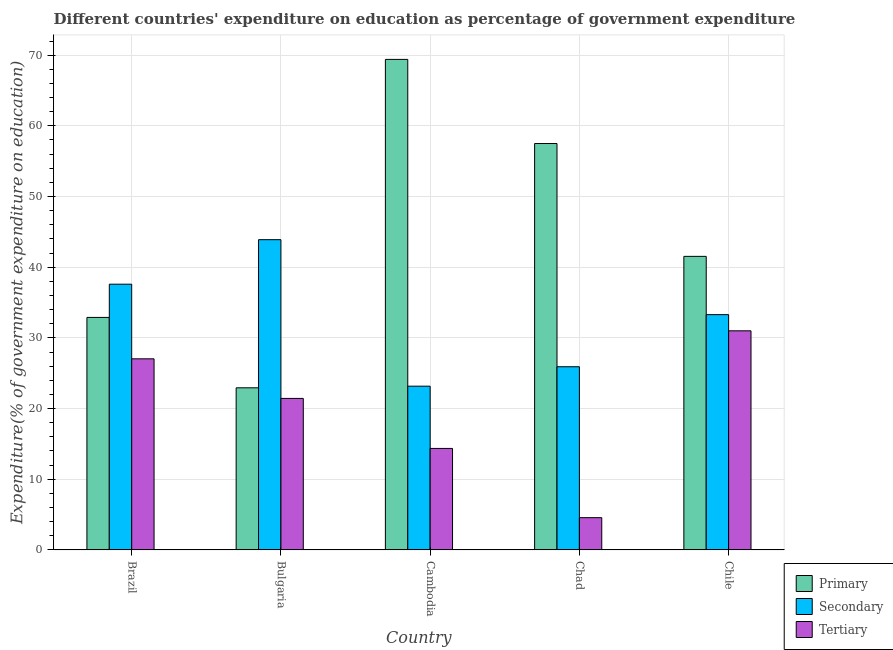How many different coloured bars are there?
Provide a succinct answer. 3. How many groups of bars are there?
Provide a short and direct response. 5. How many bars are there on the 5th tick from the right?
Make the answer very short. 3. What is the label of the 2nd group of bars from the left?
Provide a short and direct response. Bulgaria. What is the expenditure on primary education in Chile?
Your answer should be compact. 41.54. Across all countries, what is the maximum expenditure on secondary education?
Your answer should be compact. 43.9. Across all countries, what is the minimum expenditure on tertiary education?
Provide a short and direct response. 4.57. In which country was the expenditure on primary education maximum?
Your answer should be compact. Cambodia. In which country was the expenditure on secondary education minimum?
Offer a terse response. Cambodia. What is the total expenditure on secondary education in the graph?
Your answer should be very brief. 163.87. What is the difference between the expenditure on secondary education in Bulgaria and that in Cambodia?
Keep it short and to the point. 20.73. What is the difference between the expenditure on primary education in Bulgaria and the expenditure on tertiary education in Chile?
Offer a terse response. -8.06. What is the average expenditure on primary education per country?
Your answer should be compact. 44.85. What is the difference between the expenditure on secondary education and expenditure on tertiary education in Brazil?
Offer a terse response. 10.56. In how many countries, is the expenditure on tertiary education greater than 68 %?
Offer a very short reply. 0. What is the ratio of the expenditure on secondary education in Bulgaria to that in Chad?
Ensure brevity in your answer.  1.69. Is the expenditure on tertiary education in Brazil less than that in Chad?
Provide a short and direct response. No. Is the difference between the expenditure on secondary education in Bulgaria and Chile greater than the difference between the expenditure on tertiary education in Bulgaria and Chile?
Your response must be concise. Yes. What is the difference between the highest and the second highest expenditure on tertiary education?
Your answer should be compact. 3.96. What is the difference between the highest and the lowest expenditure on tertiary education?
Offer a very short reply. 26.43. What does the 2nd bar from the left in Bulgaria represents?
Offer a terse response. Secondary. What does the 2nd bar from the right in Brazil represents?
Ensure brevity in your answer.  Secondary. Is it the case that in every country, the sum of the expenditure on primary education and expenditure on secondary education is greater than the expenditure on tertiary education?
Your answer should be compact. Yes. How many bars are there?
Provide a short and direct response. 15. Are all the bars in the graph horizontal?
Provide a short and direct response. No. Are the values on the major ticks of Y-axis written in scientific E-notation?
Provide a short and direct response. No. How many legend labels are there?
Give a very brief answer. 3. How are the legend labels stacked?
Your response must be concise. Vertical. What is the title of the graph?
Make the answer very short. Different countries' expenditure on education as percentage of government expenditure. Does "Negligence towards kids" appear as one of the legend labels in the graph?
Offer a very short reply. No. What is the label or title of the X-axis?
Provide a succinct answer. Country. What is the label or title of the Y-axis?
Your answer should be very brief. Expenditure(% of government expenditure on education). What is the Expenditure(% of government expenditure on education) in Primary in Brazil?
Your answer should be compact. 32.9. What is the Expenditure(% of government expenditure on education) in Secondary in Brazil?
Provide a succinct answer. 37.6. What is the Expenditure(% of government expenditure on education) of Tertiary in Brazil?
Your answer should be very brief. 27.04. What is the Expenditure(% of government expenditure on education) in Primary in Bulgaria?
Provide a succinct answer. 22.94. What is the Expenditure(% of government expenditure on education) of Secondary in Bulgaria?
Your answer should be very brief. 43.9. What is the Expenditure(% of government expenditure on education) of Tertiary in Bulgaria?
Ensure brevity in your answer.  21.44. What is the Expenditure(% of government expenditure on education) of Primary in Cambodia?
Your answer should be compact. 69.4. What is the Expenditure(% of government expenditure on education) of Secondary in Cambodia?
Keep it short and to the point. 23.17. What is the Expenditure(% of government expenditure on education) in Tertiary in Cambodia?
Provide a succinct answer. 14.36. What is the Expenditure(% of government expenditure on education) in Primary in Chad?
Offer a very short reply. 57.5. What is the Expenditure(% of government expenditure on education) in Secondary in Chad?
Provide a succinct answer. 25.92. What is the Expenditure(% of government expenditure on education) of Tertiary in Chad?
Keep it short and to the point. 4.57. What is the Expenditure(% of government expenditure on education) in Primary in Chile?
Provide a short and direct response. 41.54. What is the Expenditure(% of government expenditure on education) in Secondary in Chile?
Provide a short and direct response. 33.29. What is the Expenditure(% of government expenditure on education) of Tertiary in Chile?
Provide a succinct answer. 31. Across all countries, what is the maximum Expenditure(% of government expenditure on education) of Primary?
Give a very brief answer. 69.4. Across all countries, what is the maximum Expenditure(% of government expenditure on education) of Secondary?
Provide a succinct answer. 43.9. Across all countries, what is the maximum Expenditure(% of government expenditure on education) in Tertiary?
Offer a terse response. 31. Across all countries, what is the minimum Expenditure(% of government expenditure on education) in Primary?
Keep it short and to the point. 22.94. Across all countries, what is the minimum Expenditure(% of government expenditure on education) in Secondary?
Offer a terse response. 23.17. Across all countries, what is the minimum Expenditure(% of government expenditure on education) of Tertiary?
Your answer should be compact. 4.57. What is the total Expenditure(% of government expenditure on education) in Primary in the graph?
Provide a succinct answer. 224.27. What is the total Expenditure(% of government expenditure on education) of Secondary in the graph?
Ensure brevity in your answer.  163.87. What is the total Expenditure(% of government expenditure on education) in Tertiary in the graph?
Make the answer very short. 98.4. What is the difference between the Expenditure(% of government expenditure on education) in Primary in Brazil and that in Bulgaria?
Ensure brevity in your answer.  9.96. What is the difference between the Expenditure(% of government expenditure on education) of Secondary in Brazil and that in Bulgaria?
Your response must be concise. -6.3. What is the difference between the Expenditure(% of government expenditure on education) in Tertiary in Brazil and that in Bulgaria?
Provide a short and direct response. 5.6. What is the difference between the Expenditure(% of government expenditure on education) of Primary in Brazil and that in Cambodia?
Your answer should be very brief. -36.5. What is the difference between the Expenditure(% of government expenditure on education) of Secondary in Brazil and that in Cambodia?
Offer a terse response. 14.43. What is the difference between the Expenditure(% of government expenditure on education) in Tertiary in Brazil and that in Cambodia?
Offer a very short reply. 12.68. What is the difference between the Expenditure(% of government expenditure on education) in Primary in Brazil and that in Chad?
Ensure brevity in your answer.  -24.6. What is the difference between the Expenditure(% of government expenditure on education) in Secondary in Brazil and that in Chad?
Your answer should be very brief. 11.68. What is the difference between the Expenditure(% of government expenditure on education) of Tertiary in Brazil and that in Chad?
Offer a terse response. 22.47. What is the difference between the Expenditure(% of government expenditure on education) in Primary in Brazil and that in Chile?
Your response must be concise. -8.64. What is the difference between the Expenditure(% of government expenditure on education) in Secondary in Brazil and that in Chile?
Provide a short and direct response. 4.31. What is the difference between the Expenditure(% of government expenditure on education) in Tertiary in Brazil and that in Chile?
Your answer should be compact. -3.96. What is the difference between the Expenditure(% of government expenditure on education) in Primary in Bulgaria and that in Cambodia?
Ensure brevity in your answer.  -46.46. What is the difference between the Expenditure(% of government expenditure on education) in Secondary in Bulgaria and that in Cambodia?
Keep it short and to the point. 20.73. What is the difference between the Expenditure(% of government expenditure on education) of Tertiary in Bulgaria and that in Cambodia?
Offer a terse response. 7.08. What is the difference between the Expenditure(% of government expenditure on education) of Primary in Bulgaria and that in Chad?
Provide a succinct answer. -34.56. What is the difference between the Expenditure(% of government expenditure on education) in Secondary in Bulgaria and that in Chad?
Make the answer very short. 17.98. What is the difference between the Expenditure(% of government expenditure on education) in Tertiary in Bulgaria and that in Chad?
Offer a very short reply. 16.87. What is the difference between the Expenditure(% of government expenditure on education) in Primary in Bulgaria and that in Chile?
Your response must be concise. -18.6. What is the difference between the Expenditure(% of government expenditure on education) of Secondary in Bulgaria and that in Chile?
Provide a succinct answer. 10.61. What is the difference between the Expenditure(% of government expenditure on education) in Tertiary in Bulgaria and that in Chile?
Ensure brevity in your answer.  -9.56. What is the difference between the Expenditure(% of government expenditure on education) in Primary in Cambodia and that in Chad?
Your answer should be compact. 11.9. What is the difference between the Expenditure(% of government expenditure on education) in Secondary in Cambodia and that in Chad?
Ensure brevity in your answer.  -2.75. What is the difference between the Expenditure(% of government expenditure on education) of Tertiary in Cambodia and that in Chad?
Your answer should be compact. 9.79. What is the difference between the Expenditure(% of government expenditure on education) of Primary in Cambodia and that in Chile?
Your response must be concise. 27.87. What is the difference between the Expenditure(% of government expenditure on education) of Secondary in Cambodia and that in Chile?
Your answer should be very brief. -10.12. What is the difference between the Expenditure(% of government expenditure on education) of Tertiary in Cambodia and that in Chile?
Provide a short and direct response. -16.64. What is the difference between the Expenditure(% of government expenditure on education) in Primary in Chad and that in Chile?
Your response must be concise. 15.96. What is the difference between the Expenditure(% of government expenditure on education) of Secondary in Chad and that in Chile?
Provide a succinct answer. -7.37. What is the difference between the Expenditure(% of government expenditure on education) in Tertiary in Chad and that in Chile?
Provide a succinct answer. -26.43. What is the difference between the Expenditure(% of government expenditure on education) in Primary in Brazil and the Expenditure(% of government expenditure on education) in Secondary in Bulgaria?
Offer a very short reply. -11. What is the difference between the Expenditure(% of government expenditure on education) of Primary in Brazil and the Expenditure(% of government expenditure on education) of Tertiary in Bulgaria?
Provide a succinct answer. 11.46. What is the difference between the Expenditure(% of government expenditure on education) of Secondary in Brazil and the Expenditure(% of government expenditure on education) of Tertiary in Bulgaria?
Provide a short and direct response. 16.16. What is the difference between the Expenditure(% of government expenditure on education) of Primary in Brazil and the Expenditure(% of government expenditure on education) of Secondary in Cambodia?
Your answer should be very brief. 9.73. What is the difference between the Expenditure(% of government expenditure on education) in Primary in Brazil and the Expenditure(% of government expenditure on education) in Tertiary in Cambodia?
Keep it short and to the point. 18.54. What is the difference between the Expenditure(% of government expenditure on education) of Secondary in Brazil and the Expenditure(% of government expenditure on education) of Tertiary in Cambodia?
Make the answer very short. 23.24. What is the difference between the Expenditure(% of government expenditure on education) in Primary in Brazil and the Expenditure(% of government expenditure on education) in Secondary in Chad?
Your response must be concise. 6.98. What is the difference between the Expenditure(% of government expenditure on education) of Primary in Brazil and the Expenditure(% of government expenditure on education) of Tertiary in Chad?
Offer a terse response. 28.33. What is the difference between the Expenditure(% of government expenditure on education) of Secondary in Brazil and the Expenditure(% of government expenditure on education) of Tertiary in Chad?
Provide a short and direct response. 33.03. What is the difference between the Expenditure(% of government expenditure on education) of Primary in Brazil and the Expenditure(% of government expenditure on education) of Secondary in Chile?
Your answer should be compact. -0.39. What is the difference between the Expenditure(% of government expenditure on education) in Primary in Brazil and the Expenditure(% of government expenditure on education) in Tertiary in Chile?
Your response must be concise. 1.9. What is the difference between the Expenditure(% of government expenditure on education) in Secondary in Brazil and the Expenditure(% of government expenditure on education) in Tertiary in Chile?
Give a very brief answer. 6.6. What is the difference between the Expenditure(% of government expenditure on education) in Primary in Bulgaria and the Expenditure(% of government expenditure on education) in Secondary in Cambodia?
Offer a terse response. -0.23. What is the difference between the Expenditure(% of government expenditure on education) of Primary in Bulgaria and the Expenditure(% of government expenditure on education) of Tertiary in Cambodia?
Make the answer very short. 8.58. What is the difference between the Expenditure(% of government expenditure on education) of Secondary in Bulgaria and the Expenditure(% of government expenditure on education) of Tertiary in Cambodia?
Keep it short and to the point. 29.54. What is the difference between the Expenditure(% of government expenditure on education) in Primary in Bulgaria and the Expenditure(% of government expenditure on education) in Secondary in Chad?
Keep it short and to the point. -2.98. What is the difference between the Expenditure(% of government expenditure on education) of Primary in Bulgaria and the Expenditure(% of government expenditure on education) of Tertiary in Chad?
Ensure brevity in your answer.  18.37. What is the difference between the Expenditure(% of government expenditure on education) of Secondary in Bulgaria and the Expenditure(% of government expenditure on education) of Tertiary in Chad?
Keep it short and to the point. 39.33. What is the difference between the Expenditure(% of government expenditure on education) of Primary in Bulgaria and the Expenditure(% of government expenditure on education) of Secondary in Chile?
Offer a very short reply. -10.35. What is the difference between the Expenditure(% of government expenditure on education) in Primary in Bulgaria and the Expenditure(% of government expenditure on education) in Tertiary in Chile?
Keep it short and to the point. -8.06. What is the difference between the Expenditure(% of government expenditure on education) in Secondary in Bulgaria and the Expenditure(% of government expenditure on education) in Tertiary in Chile?
Offer a terse response. 12.9. What is the difference between the Expenditure(% of government expenditure on education) of Primary in Cambodia and the Expenditure(% of government expenditure on education) of Secondary in Chad?
Give a very brief answer. 43.48. What is the difference between the Expenditure(% of government expenditure on education) in Primary in Cambodia and the Expenditure(% of government expenditure on education) in Tertiary in Chad?
Your response must be concise. 64.84. What is the difference between the Expenditure(% of government expenditure on education) in Secondary in Cambodia and the Expenditure(% of government expenditure on education) in Tertiary in Chad?
Your answer should be compact. 18.6. What is the difference between the Expenditure(% of government expenditure on education) of Primary in Cambodia and the Expenditure(% of government expenditure on education) of Secondary in Chile?
Make the answer very short. 36.11. What is the difference between the Expenditure(% of government expenditure on education) in Primary in Cambodia and the Expenditure(% of government expenditure on education) in Tertiary in Chile?
Ensure brevity in your answer.  38.4. What is the difference between the Expenditure(% of government expenditure on education) of Secondary in Cambodia and the Expenditure(% of government expenditure on education) of Tertiary in Chile?
Provide a short and direct response. -7.83. What is the difference between the Expenditure(% of government expenditure on education) in Primary in Chad and the Expenditure(% of government expenditure on education) in Secondary in Chile?
Your response must be concise. 24.21. What is the difference between the Expenditure(% of government expenditure on education) in Primary in Chad and the Expenditure(% of government expenditure on education) in Tertiary in Chile?
Give a very brief answer. 26.5. What is the difference between the Expenditure(% of government expenditure on education) in Secondary in Chad and the Expenditure(% of government expenditure on education) in Tertiary in Chile?
Ensure brevity in your answer.  -5.08. What is the average Expenditure(% of government expenditure on education) in Primary per country?
Give a very brief answer. 44.85. What is the average Expenditure(% of government expenditure on education) of Secondary per country?
Offer a terse response. 32.77. What is the average Expenditure(% of government expenditure on education) of Tertiary per country?
Your answer should be compact. 19.68. What is the difference between the Expenditure(% of government expenditure on education) in Primary and Expenditure(% of government expenditure on education) in Secondary in Brazil?
Provide a succinct answer. -4.7. What is the difference between the Expenditure(% of government expenditure on education) in Primary and Expenditure(% of government expenditure on education) in Tertiary in Brazil?
Ensure brevity in your answer.  5.86. What is the difference between the Expenditure(% of government expenditure on education) of Secondary and Expenditure(% of government expenditure on education) of Tertiary in Brazil?
Your response must be concise. 10.56. What is the difference between the Expenditure(% of government expenditure on education) of Primary and Expenditure(% of government expenditure on education) of Secondary in Bulgaria?
Give a very brief answer. -20.96. What is the difference between the Expenditure(% of government expenditure on education) in Primary and Expenditure(% of government expenditure on education) in Tertiary in Bulgaria?
Ensure brevity in your answer.  1.5. What is the difference between the Expenditure(% of government expenditure on education) in Secondary and Expenditure(% of government expenditure on education) in Tertiary in Bulgaria?
Make the answer very short. 22.46. What is the difference between the Expenditure(% of government expenditure on education) of Primary and Expenditure(% of government expenditure on education) of Secondary in Cambodia?
Your answer should be compact. 46.23. What is the difference between the Expenditure(% of government expenditure on education) of Primary and Expenditure(% of government expenditure on education) of Tertiary in Cambodia?
Give a very brief answer. 55.04. What is the difference between the Expenditure(% of government expenditure on education) in Secondary and Expenditure(% of government expenditure on education) in Tertiary in Cambodia?
Make the answer very short. 8.81. What is the difference between the Expenditure(% of government expenditure on education) in Primary and Expenditure(% of government expenditure on education) in Secondary in Chad?
Your answer should be compact. 31.58. What is the difference between the Expenditure(% of government expenditure on education) in Primary and Expenditure(% of government expenditure on education) in Tertiary in Chad?
Your response must be concise. 52.93. What is the difference between the Expenditure(% of government expenditure on education) in Secondary and Expenditure(% of government expenditure on education) in Tertiary in Chad?
Provide a succinct answer. 21.35. What is the difference between the Expenditure(% of government expenditure on education) of Primary and Expenditure(% of government expenditure on education) of Secondary in Chile?
Your response must be concise. 8.24. What is the difference between the Expenditure(% of government expenditure on education) of Primary and Expenditure(% of government expenditure on education) of Tertiary in Chile?
Give a very brief answer. 10.53. What is the difference between the Expenditure(% of government expenditure on education) in Secondary and Expenditure(% of government expenditure on education) in Tertiary in Chile?
Offer a terse response. 2.29. What is the ratio of the Expenditure(% of government expenditure on education) of Primary in Brazil to that in Bulgaria?
Provide a short and direct response. 1.43. What is the ratio of the Expenditure(% of government expenditure on education) in Secondary in Brazil to that in Bulgaria?
Your response must be concise. 0.86. What is the ratio of the Expenditure(% of government expenditure on education) of Tertiary in Brazil to that in Bulgaria?
Offer a terse response. 1.26. What is the ratio of the Expenditure(% of government expenditure on education) in Primary in Brazil to that in Cambodia?
Your answer should be very brief. 0.47. What is the ratio of the Expenditure(% of government expenditure on education) of Secondary in Brazil to that in Cambodia?
Keep it short and to the point. 1.62. What is the ratio of the Expenditure(% of government expenditure on education) of Tertiary in Brazil to that in Cambodia?
Provide a short and direct response. 1.88. What is the ratio of the Expenditure(% of government expenditure on education) of Primary in Brazil to that in Chad?
Keep it short and to the point. 0.57. What is the ratio of the Expenditure(% of government expenditure on education) of Secondary in Brazil to that in Chad?
Make the answer very short. 1.45. What is the ratio of the Expenditure(% of government expenditure on education) of Tertiary in Brazil to that in Chad?
Your response must be concise. 5.92. What is the ratio of the Expenditure(% of government expenditure on education) of Primary in Brazil to that in Chile?
Offer a very short reply. 0.79. What is the ratio of the Expenditure(% of government expenditure on education) of Secondary in Brazil to that in Chile?
Provide a succinct answer. 1.13. What is the ratio of the Expenditure(% of government expenditure on education) in Tertiary in Brazil to that in Chile?
Offer a very short reply. 0.87. What is the ratio of the Expenditure(% of government expenditure on education) of Primary in Bulgaria to that in Cambodia?
Your answer should be very brief. 0.33. What is the ratio of the Expenditure(% of government expenditure on education) of Secondary in Bulgaria to that in Cambodia?
Make the answer very short. 1.89. What is the ratio of the Expenditure(% of government expenditure on education) in Tertiary in Bulgaria to that in Cambodia?
Offer a very short reply. 1.49. What is the ratio of the Expenditure(% of government expenditure on education) in Primary in Bulgaria to that in Chad?
Offer a terse response. 0.4. What is the ratio of the Expenditure(% of government expenditure on education) in Secondary in Bulgaria to that in Chad?
Your answer should be compact. 1.69. What is the ratio of the Expenditure(% of government expenditure on education) in Tertiary in Bulgaria to that in Chad?
Offer a terse response. 4.7. What is the ratio of the Expenditure(% of government expenditure on education) of Primary in Bulgaria to that in Chile?
Give a very brief answer. 0.55. What is the ratio of the Expenditure(% of government expenditure on education) of Secondary in Bulgaria to that in Chile?
Offer a very short reply. 1.32. What is the ratio of the Expenditure(% of government expenditure on education) in Tertiary in Bulgaria to that in Chile?
Provide a succinct answer. 0.69. What is the ratio of the Expenditure(% of government expenditure on education) in Primary in Cambodia to that in Chad?
Your response must be concise. 1.21. What is the ratio of the Expenditure(% of government expenditure on education) in Secondary in Cambodia to that in Chad?
Provide a short and direct response. 0.89. What is the ratio of the Expenditure(% of government expenditure on education) in Tertiary in Cambodia to that in Chad?
Your answer should be compact. 3.15. What is the ratio of the Expenditure(% of government expenditure on education) of Primary in Cambodia to that in Chile?
Provide a succinct answer. 1.67. What is the ratio of the Expenditure(% of government expenditure on education) of Secondary in Cambodia to that in Chile?
Offer a very short reply. 0.7. What is the ratio of the Expenditure(% of government expenditure on education) in Tertiary in Cambodia to that in Chile?
Your answer should be compact. 0.46. What is the ratio of the Expenditure(% of government expenditure on education) of Primary in Chad to that in Chile?
Your answer should be very brief. 1.38. What is the ratio of the Expenditure(% of government expenditure on education) of Secondary in Chad to that in Chile?
Make the answer very short. 0.78. What is the ratio of the Expenditure(% of government expenditure on education) in Tertiary in Chad to that in Chile?
Your response must be concise. 0.15. What is the difference between the highest and the second highest Expenditure(% of government expenditure on education) of Primary?
Your answer should be compact. 11.9. What is the difference between the highest and the second highest Expenditure(% of government expenditure on education) of Secondary?
Give a very brief answer. 6.3. What is the difference between the highest and the second highest Expenditure(% of government expenditure on education) of Tertiary?
Provide a succinct answer. 3.96. What is the difference between the highest and the lowest Expenditure(% of government expenditure on education) of Primary?
Give a very brief answer. 46.46. What is the difference between the highest and the lowest Expenditure(% of government expenditure on education) in Secondary?
Your answer should be compact. 20.73. What is the difference between the highest and the lowest Expenditure(% of government expenditure on education) of Tertiary?
Your response must be concise. 26.43. 